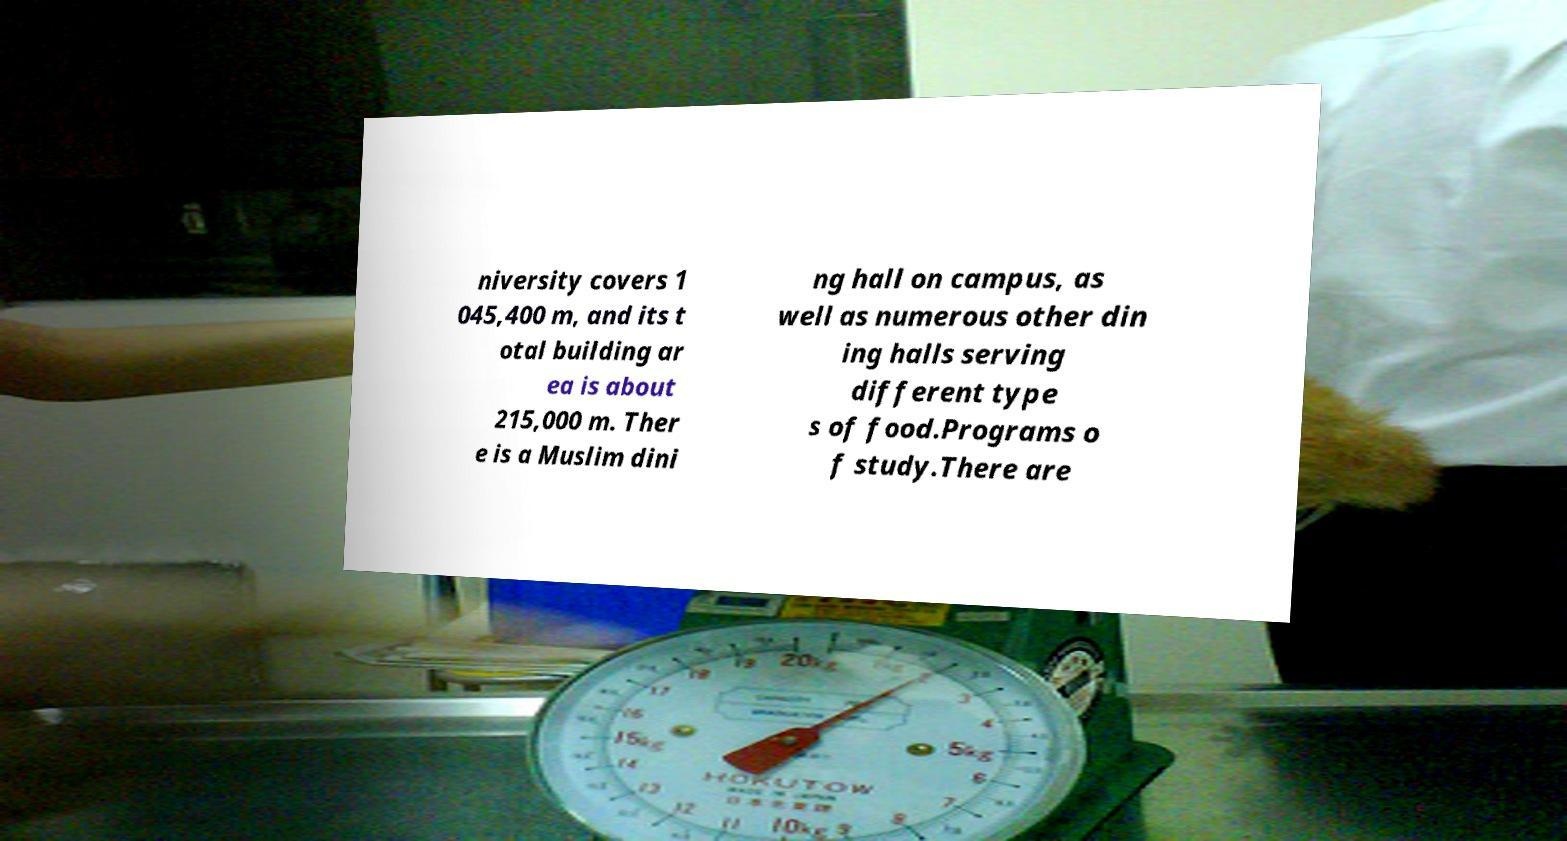There's text embedded in this image that I need extracted. Can you transcribe it verbatim? niversity covers 1 045,400 m, and its t otal building ar ea is about 215,000 m. Ther e is a Muslim dini ng hall on campus, as well as numerous other din ing halls serving different type s of food.Programs o f study.There are 